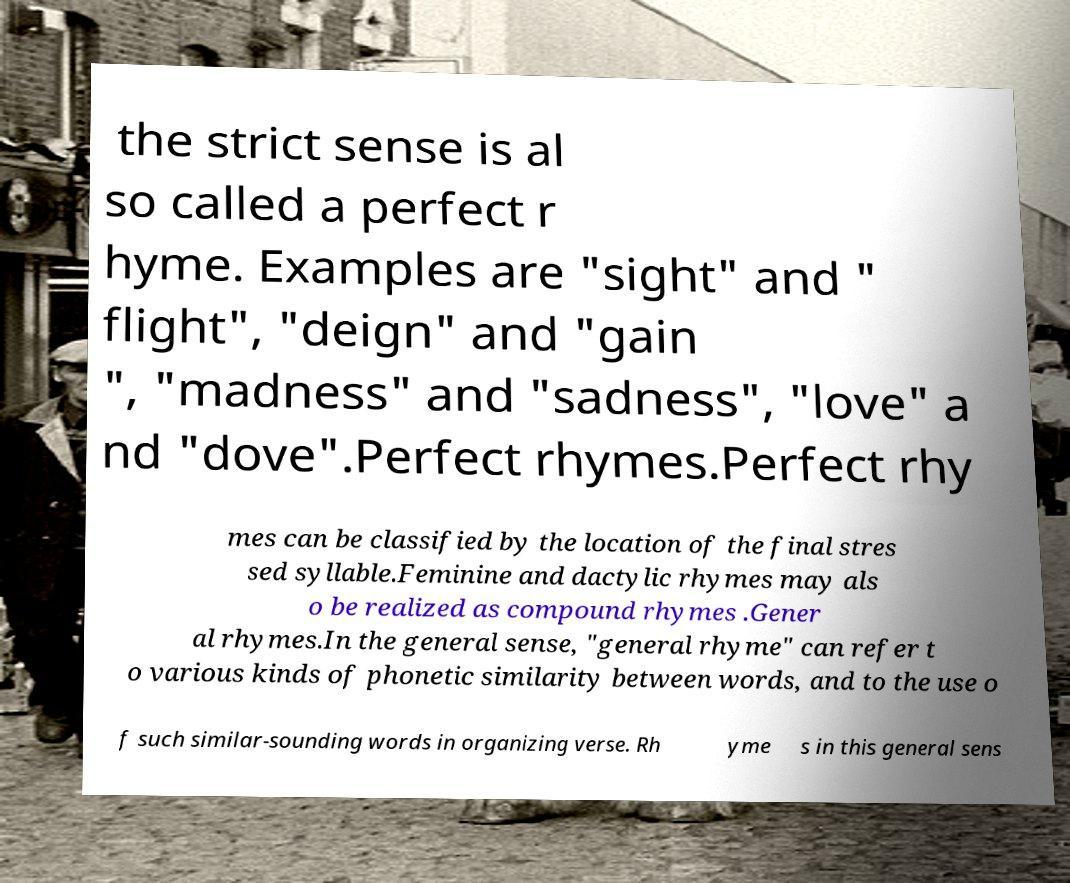Can you read and provide the text displayed in the image?This photo seems to have some interesting text. Can you extract and type it out for me? the strict sense is al so called a perfect r hyme. Examples are "sight" and " flight", "deign" and "gain ", "madness" and "sadness", "love" a nd "dove".Perfect rhymes.Perfect rhy mes can be classified by the location of the final stres sed syllable.Feminine and dactylic rhymes may als o be realized as compound rhymes .Gener al rhymes.In the general sense, "general rhyme" can refer t o various kinds of phonetic similarity between words, and to the use o f such similar-sounding words in organizing verse. Rh yme s in this general sens 